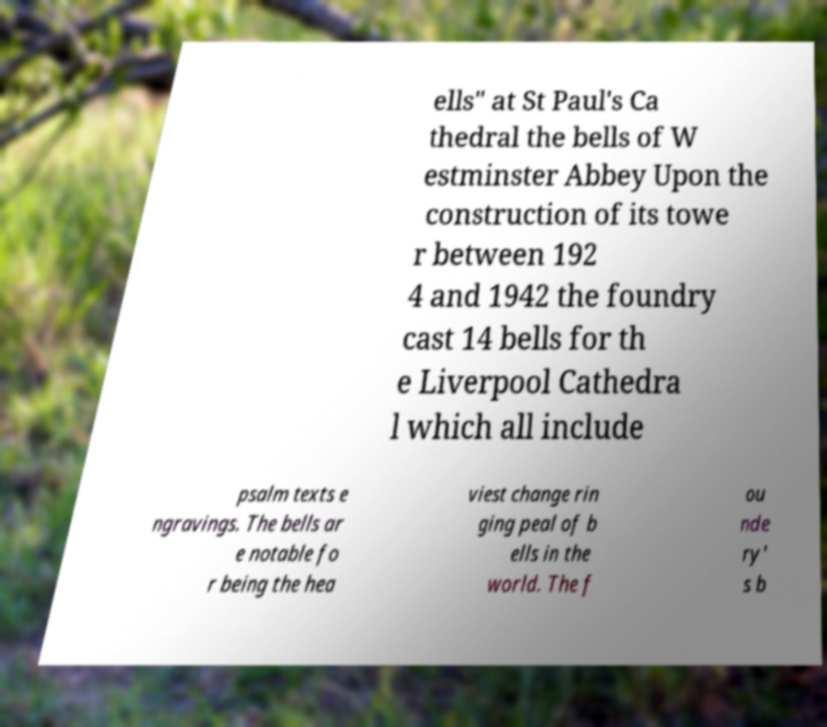Could you extract and type out the text from this image? ells" at St Paul's Ca thedral the bells of W estminster Abbey Upon the construction of its towe r between 192 4 and 1942 the foundry cast 14 bells for th e Liverpool Cathedra l which all include psalm texts e ngravings. The bells ar e notable fo r being the hea viest change rin ging peal of b ells in the world. The f ou nde ry' s b 